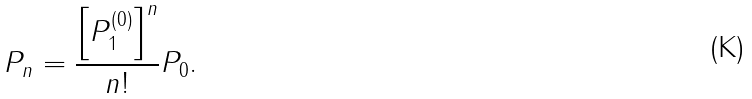<formula> <loc_0><loc_0><loc_500><loc_500>P _ { n } = \frac { \left [ P _ { 1 } ^ { \left ( 0 \right ) } \right ] ^ { n } } { n ! } P _ { 0 } .</formula> 